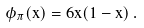<formula> <loc_0><loc_0><loc_500><loc_500>\phi _ { \pi } ( x ) = 6 x ( 1 - x ) \, .</formula> 